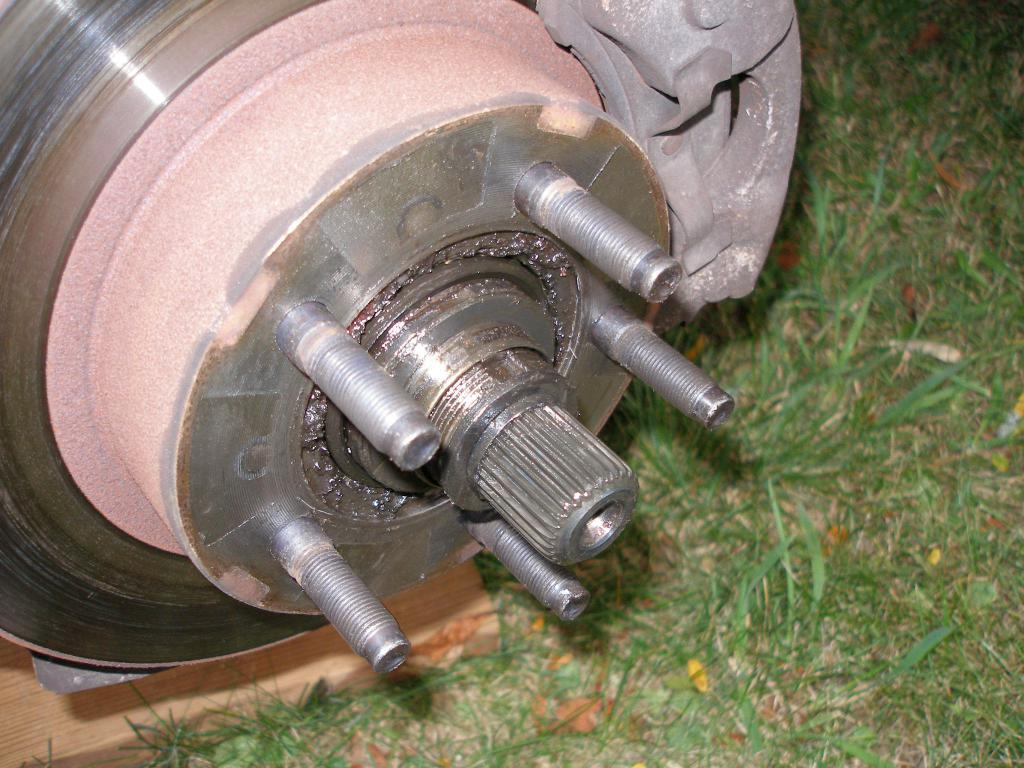What is the main subject of the image? The main subject of the image is a wheel axle of a car. What is attached to the wheel axle? The wheel axle has break plates and bolts attached to it. What is supporting the wheel axle in the image? There is a wooden plank under the wheel axle. What type of surface is the wooden plank on? The wooden plank is on a grass surface. How does the beggar interact with the wheel axle in the image? There is no beggar present in the image, so it is not possible to answer that question. 